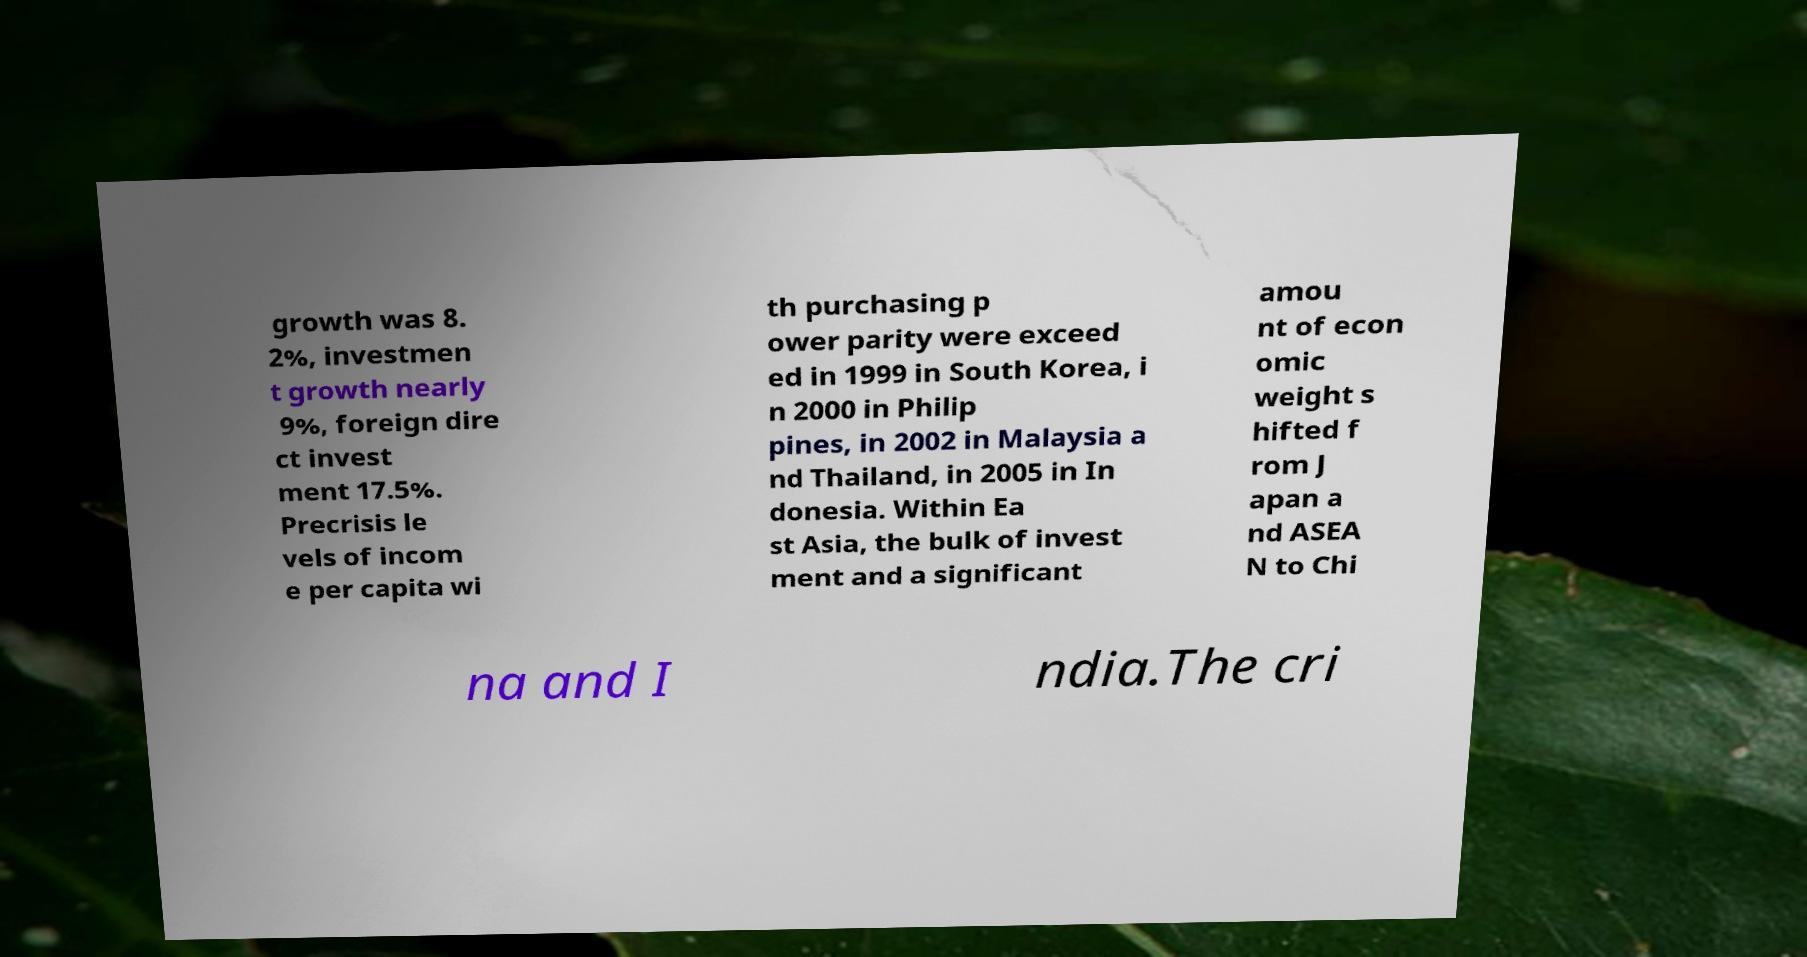Please identify and transcribe the text found in this image. growth was 8. 2%, investmen t growth nearly 9%, foreign dire ct invest ment 17.5%. Precrisis le vels of incom e per capita wi th purchasing p ower parity were exceed ed in 1999 in South Korea, i n 2000 in Philip pines, in 2002 in Malaysia a nd Thailand, in 2005 in In donesia. Within Ea st Asia, the bulk of invest ment and a significant amou nt of econ omic weight s hifted f rom J apan a nd ASEA N to Chi na and I ndia.The cri 